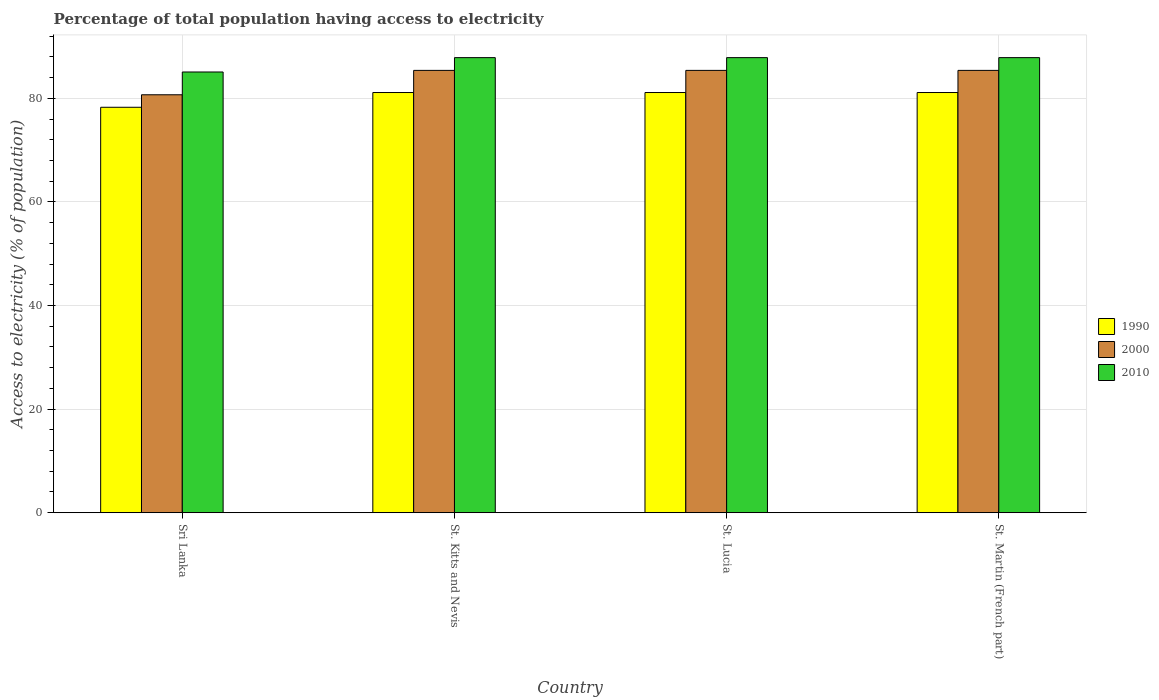How many groups of bars are there?
Your answer should be very brief. 4. How many bars are there on the 4th tick from the left?
Offer a terse response. 3. How many bars are there on the 1st tick from the right?
Your response must be concise. 3. What is the label of the 1st group of bars from the left?
Provide a short and direct response. Sri Lanka. In how many cases, is the number of bars for a given country not equal to the number of legend labels?
Offer a very short reply. 0. What is the percentage of population that have access to electricity in 2000 in Sri Lanka?
Your answer should be compact. 80.7. Across all countries, what is the maximum percentage of population that have access to electricity in 2010?
Your answer should be compact. 87.87. Across all countries, what is the minimum percentage of population that have access to electricity in 2000?
Your answer should be compact. 80.7. In which country was the percentage of population that have access to electricity in 2010 maximum?
Offer a very short reply. St. Kitts and Nevis. In which country was the percentage of population that have access to electricity in 1990 minimum?
Keep it short and to the point. Sri Lanka. What is the total percentage of population that have access to electricity in 1990 in the graph?
Provide a succinct answer. 321.69. What is the difference between the percentage of population that have access to electricity in 1990 in St. Lucia and that in St. Martin (French part)?
Offer a very short reply. 0. What is the difference between the percentage of population that have access to electricity in 2010 in St. Kitts and Nevis and the percentage of population that have access to electricity in 1990 in St. Martin (French part)?
Provide a succinct answer. 6.74. What is the average percentage of population that have access to electricity in 2010 per country?
Your answer should be compact. 87.18. What is the difference between the percentage of population that have access to electricity of/in 1990 and percentage of population that have access to electricity of/in 2000 in St. Kitts and Nevis?
Your answer should be very brief. -4.28. In how many countries, is the percentage of population that have access to electricity in 2010 greater than 28 %?
Offer a terse response. 4. What is the ratio of the percentage of population that have access to electricity in 2010 in Sri Lanka to that in St. Kitts and Nevis?
Keep it short and to the point. 0.97. What is the difference between the highest and the lowest percentage of population that have access to electricity in 2010?
Your answer should be compact. 2.77. What does the 3rd bar from the left in St. Kitts and Nevis represents?
Keep it short and to the point. 2010. Is it the case that in every country, the sum of the percentage of population that have access to electricity in 2010 and percentage of population that have access to electricity in 2000 is greater than the percentage of population that have access to electricity in 1990?
Your answer should be very brief. Yes. How many bars are there?
Make the answer very short. 12. Are all the bars in the graph horizontal?
Keep it short and to the point. No. How many countries are there in the graph?
Your response must be concise. 4. What is the difference between two consecutive major ticks on the Y-axis?
Offer a very short reply. 20. How many legend labels are there?
Provide a succinct answer. 3. How are the legend labels stacked?
Offer a very short reply. Vertical. What is the title of the graph?
Make the answer very short. Percentage of total population having access to electricity. Does "1986" appear as one of the legend labels in the graph?
Your response must be concise. No. What is the label or title of the X-axis?
Make the answer very short. Country. What is the label or title of the Y-axis?
Provide a short and direct response. Access to electricity (% of population). What is the Access to electricity (% of population) of 1990 in Sri Lanka?
Your response must be concise. 78.29. What is the Access to electricity (% of population) of 2000 in Sri Lanka?
Your answer should be compact. 80.7. What is the Access to electricity (% of population) of 2010 in Sri Lanka?
Provide a short and direct response. 85.1. What is the Access to electricity (% of population) of 1990 in St. Kitts and Nevis?
Keep it short and to the point. 81.14. What is the Access to electricity (% of population) in 2000 in St. Kitts and Nevis?
Make the answer very short. 85.41. What is the Access to electricity (% of population) in 2010 in St. Kitts and Nevis?
Offer a very short reply. 87.87. What is the Access to electricity (% of population) in 1990 in St. Lucia?
Your response must be concise. 81.14. What is the Access to electricity (% of population) of 2000 in St. Lucia?
Offer a very short reply. 85.41. What is the Access to electricity (% of population) in 2010 in St. Lucia?
Your answer should be very brief. 87.87. What is the Access to electricity (% of population) in 1990 in St. Martin (French part)?
Provide a short and direct response. 81.14. What is the Access to electricity (% of population) in 2000 in St. Martin (French part)?
Give a very brief answer. 85.41. What is the Access to electricity (% of population) of 2010 in St. Martin (French part)?
Offer a very short reply. 87.87. Across all countries, what is the maximum Access to electricity (% of population) of 1990?
Offer a terse response. 81.14. Across all countries, what is the maximum Access to electricity (% of population) of 2000?
Provide a succinct answer. 85.41. Across all countries, what is the maximum Access to electricity (% of population) in 2010?
Make the answer very short. 87.87. Across all countries, what is the minimum Access to electricity (% of population) in 1990?
Offer a very short reply. 78.29. Across all countries, what is the minimum Access to electricity (% of population) in 2000?
Provide a succinct answer. 80.7. Across all countries, what is the minimum Access to electricity (% of population) in 2010?
Your answer should be very brief. 85.1. What is the total Access to electricity (% of population) of 1990 in the graph?
Provide a succinct answer. 321.69. What is the total Access to electricity (% of population) of 2000 in the graph?
Keep it short and to the point. 336.93. What is the total Access to electricity (% of population) in 2010 in the graph?
Provide a short and direct response. 348.72. What is the difference between the Access to electricity (% of population) in 1990 in Sri Lanka and that in St. Kitts and Nevis?
Provide a succinct answer. -2.85. What is the difference between the Access to electricity (% of population) in 2000 in Sri Lanka and that in St. Kitts and Nevis?
Your answer should be compact. -4.71. What is the difference between the Access to electricity (% of population) in 2010 in Sri Lanka and that in St. Kitts and Nevis?
Offer a terse response. -2.77. What is the difference between the Access to electricity (% of population) of 1990 in Sri Lanka and that in St. Lucia?
Offer a terse response. -2.85. What is the difference between the Access to electricity (% of population) of 2000 in Sri Lanka and that in St. Lucia?
Provide a succinct answer. -4.71. What is the difference between the Access to electricity (% of population) in 2010 in Sri Lanka and that in St. Lucia?
Provide a short and direct response. -2.77. What is the difference between the Access to electricity (% of population) of 1990 in Sri Lanka and that in St. Martin (French part)?
Give a very brief answer. -2.85. What is the difference between the Access to electricity (% of population) in 2000 in Sri Lanka and that in St. Martin (French part)?
Your answer should be compact. -4.71. What is the difference between the Access to electricity (% of population) in 2010 in Sri Lanka and that in St. Martin (French part)?
Offer a very short reply. -2.77. What is the difference between the Access to electricity (% of population) of 1990 in St. Kitts and Nevis and that in St. Lucia?
Your answer should be very brief. 0. What is the difference between the Access to electricity (% of population) in 1990 in St. Kitts and Nevis and that in St. Martin (French part)?
Provide a succinct answer. 0. What is the difference between the Access to electricity (% of population) in 1990 in Sri Lanka and the Access to electricity (% of population) in 2000 in St. Kitts and Nevis?
Give a very brief answer. -7.12. What is the difference between the Access to electricity (% of population) in 1990 in Sri Lanka and the Access to electricity (% of population) in 2010 in St. Kitts and Nevis?
Provide a short and direct response. -9.59. What is the difference between the Access to electricity (% of population) in 2000 in Sri Lanka and the Access to electricity (% of population) in 2010 in St. Kitts and Nevis?
Offer a terse response. -7.17. What is the difference between the Access to electricity (% of population) in 1990 in Sri Lanka and the Access to electricity (% of population) in 2000 in St. Lucia?
Keep it short and to the point. -7.12. What is the difference between the Access to electricity (% of population) in 1990 in Sri Lanka and the Access to electricity (% of population) in 2010 in St. Lucia?
Your response must be concise. -9.59. What is the difference between the Access to electricity (% of population) of 2000 in Sri Lanka and the Access to electricity (% of population) of 2010 in St. Lucia?
Provide a succinct answer. -7.17. What is the difference between the Access to electricity (% of population) in 1990 in Sri Lanka and the Access to electricity (% of population) in 2000 in St. Martin (French part)?
Your answer should be very brief. -7.12. What is the difference between the Access to electricity (% of population) of 1990 in Sri Lanka and the Access to electricity (% of population) of 2010 in St. Martin (French part)?
Give a very brief answer. -9.59. What is the difference between the Access to electricity (% of population) in 2000 in Sri Lanka and the Access to electricity (% of population) in 2010 in St. Martin (French part)?
Offer a very short reply. -7.17. What is the difference between the Access to electricity (% of population) of 1990 in St. Kitts and Nevis and the Access to electricity (% of population) of 2000 in St. Lucia?
Make the answer very short. -4.28. What is the difference between the Access to electricity (% of population) in 1990 in St. Kitts and Nevis and the Access to electricity (% of population) in 2010 in St. Lucia?
Make the answer very short. -6.74. What is the difference between the Access to electricity (% of population) in 2000 in St. Kitts and Nevis and the Access to electricity (% of population) in 2010 in St. Lucia?
Make the answer very short. -2.46. What is the difference between the Access to electricity (% of population) in 1990 in St. Kitts and Nevis and the Access to electricity (% of population) in 2000 in St. Martin (French part)?
Provide a short and direct response. -4.28. What is the difference between the Access to electricity (% of population) in 1990 in St. Kitts and Nevis and the Access to electricity (% of population) in 2010 in St. Martin (French part)?
Offer a very short reply. -6.74. What is the difference between the Access to electricity (% of population) in 2000 in St. Kitts and Nevis and the Access to electricity (% of population) in 2010 in St. Martin (French part)?
Provide a succinct answer. -2.46. What is the difference between the Access to electricity (% of population) of 1990 in St. Lucia and the Access to electricity (% of population) of 2000 in St. Martin (French part)?
Keep it short and to the point. -4.28. What is the difference between the Access to electricity (% of population) in 1990 in St. Lucia and the Access to electricity (% of population) in 2010 in St. Martin (French part)?
Provide a short and direct response. -6.74. What is the difference between the Access to electricity (% of population) of 2000 in St. Lucia and the Access to electricity (% of population) of 2010 in St. Martin (French part)?
Ensure brevity in your answer.  -2.46. What is the average Access to electricity (% of population) of 1990 per country?
Give a very brief answer. 80.42. What is the average Access to electricity (% of population) of 2000 per country?
Offer a terse response. 84.23. What is the average Access to electricity (% of population) in 2010 per country?
Your answer should be compact. 87.18. What is the difference between the Access to electricity (% of population) in 1990 and Access to electricity (% of population) in 2000 in Sri Lanka?
Offer a very short reply. -2.41. What is the difference between the Access to electricity (% of population) in 1990 and Access to electricity (% of population) in 2010 in Sri Lanka?
Your answer should be very brief. -6.81. What is the difference between the Access to electricity (% of population) of 1990 and Access to electricity (% of population) of 2000 in St. Kitts and Nevis?
Make the answer very short. -4.28. What is the difference between the Access to electricity (% of population) in 1990 and Access to electricity (% of population) in 2010 in St. Kitts and Nevis?
Your answer should be compact. -6.74. What is the difference between the Access to electricity (% of population) in 2000 and Access to electricity (% of population) in 2010 in St. Kitts and Nevis?
Offer a terse response. -2.46. What is the difference between the Access to electricity (% of population) of 1990 and Access to electricity (% of population) of 2000 in St. Lucia?
Provide a succinct answer. -4.28. What is the difference between the Access to electricity (% of population) of 1990 and Access to electricity (% of population) of 2010 in St. Lucia?
Your answer should be compact. -6.74. What is the difference between the Access to electricity (% of population) of 2000 and Access to electricity (% of population) of 2010 in St. Lucia?
Give a very brief answer. -2.46. What is the difference between the Access to electricity (% of population) in 1990 and Access to electricity (% of population) in 2000 in St. Martin (French part)?
Offer a terse response. -4.28. What is the difference between the Access to electricity (% of population) in 1990 and Access to electricity (% of population) in 2010 in St. Martin (French part)?
Give a very brief answer. -6.74. What is the difference between the Access to electricity (% of population) in 2000 and Access to electricity (% of population) in 2010 in St. Martin (French part)?
Provide a short and direct response. -2.46. What is the ratio of the Access to electricity (% of population) in 1990 in Sri Lanka to that in St. Kitts and Nevis?
Provide a succinct answer. 0.96. What is the ratio of the Access to electricity (% of population) in 2000 in Sri Lanka to that in St. Kitts and Nevis?
Ensure brevity in your answer.  0.94. What is the ratio of the Access to electricity (% of population) in 2010 in Sri Lanka to that in St. Kitts and Nevis?
Provide a short and direct response. 0.97. What is the ratio of the Access to electricity (% of population) of 1990 in Sri Lanka to that in St. Lucia?
Offer a very short reply. 0.96. What is the ratio of the Access to electricity (% of population) of 2000 in Sri Lanka to that in St. Lucia?
Make the answer very short. 0.94. What is the ratio of the Access to electricity (% of population) of 2010 in Sri Lanka to that in St. Lucia?
Your answer should be very brief. 0.97. What is the ratio of the Access to electricity (% of population) of 1990 in Sri Lanka to that in St. Martin (French part)?
Make the answer very short. 0.96. What is the ratio of the Access to electricity (% of population) in 2000 in Sri Lanka to that in St. Martin (French part)?
Offer a very short reply. 0.94. What is the ratio of the Access to electricity (% of population) in 2010 in Sri Lanka to that in St. Martin (French part)?
Your response must be concise. 0.97. What is the ratio of the Access to electricity (% of population) of 2000 in St. Kitts and Nevis to that in St. Lucia?
Provide a short and direct response. 1. What is the ratio of the Access to electricity (% of population) of 1990 in St. Kitts and Nevis to that in St. Martin (French part)?
Provide a short and direct response. 1. What is the ratio of the Access to electricity (% of population) of 2000 in St. Kitts and Nevis to that in St. Martin (French part)?
Make the answer very short. 1. What is the ratio of the Access to electricity (% of population) in 2010 in St. Kitts and Nevis to that in St. Martin (French part)?
Your answer should be very brief. 1. What is the ratio of the Access to electricity (% of population) in 2000 in St. Lucia to that in St. Martin (French part)?
Ensure brevity in your answer.  1. What is the ratio of the Access to electricity (% of population) of 2010 in St. Lucia to that in St. Martin (French part)?
Your answer should be compact. 1. What is the difference between the highest and the second highest Access to electricity (% of population) in 1990?
Offer a terse response. 0. What is the difference between the highest and the second highest Access to electricity (% of population) of 2000?
Provide a short and direct response. 0. What is the difference between the highest and the lowest Access to electricity (% of population) in 1990?
Offer a very short reply. 2.85. What is the difference between the highest and the lowest Access to electricity (% of population) in 2000?
Give a very brief answer. 4.71. What is the difference between the highest and the lowest Access to electricity (% of population) of 2010?
Your response must be concise. 2.77. 